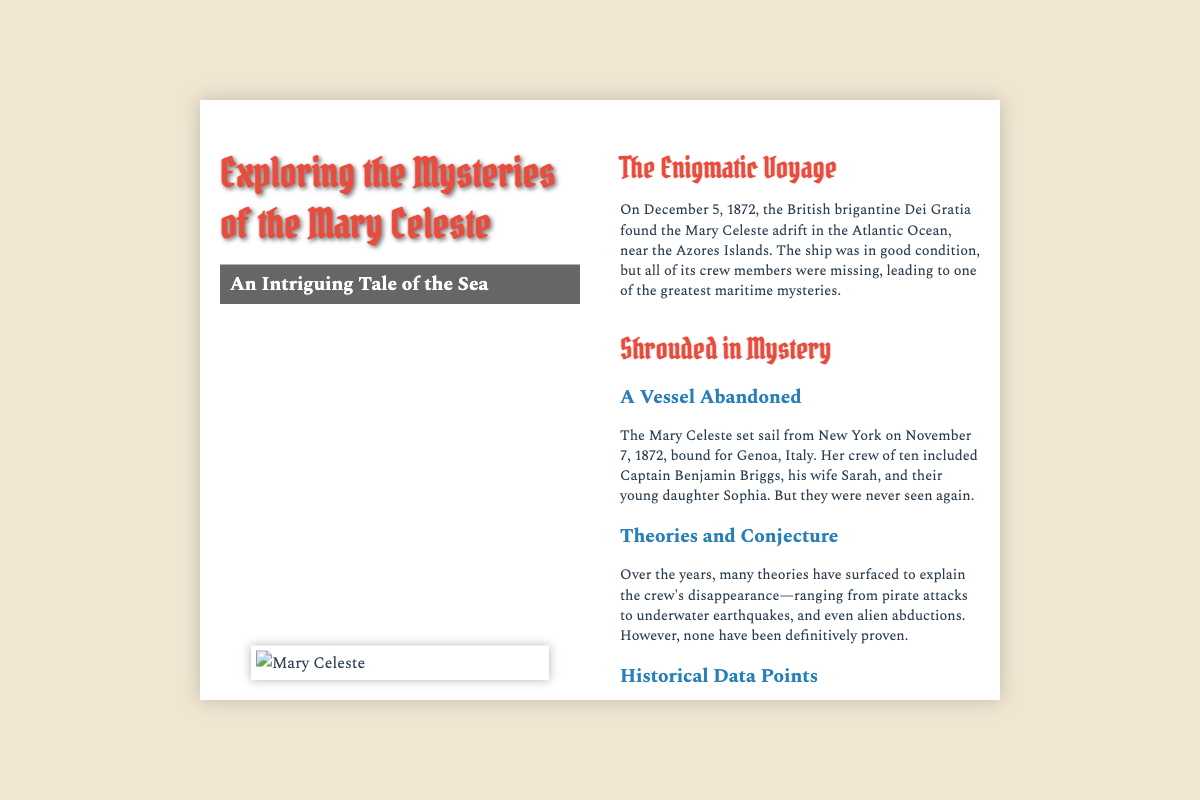What date was the Mary Celeste found? The Mary Celeste was found on December 5, 1872, by the British brigantine Dei Gratia.
Answer: December 5, 1872 Who was the captain of the Mary Celeste? The captain of the Mary Celeste was Benjamin Briggs.
Answer: Benjamin Briggs How many crew members were missing when the Mary Celeste was found? The ship was found with all ten crew members missing.
Answer: Ten What was the last date recorded in the ship's logbook? The ship's logbook ended abruptly on November 25, 1872.
Answer: November 25, 1872 What is one theory about the crew's disappearance? Theories include pirate attacks and underwater earthquakes.
Answer: Pirate attacks What did the condition of the ship suggest? The ship was in good condition, which indicates it hadn't sunk or met with a disaster.
Answer: Good condition What was found missing from the Mary Celeste? The lifeboat was missing, suggesting a hurried evacuation of the crew.
Answer: Lifeboat What relationship did Sarah Briggs have to Captain Benjamin Briggs? Sarah Briggs was the captain's wife.
Answer: Wife 